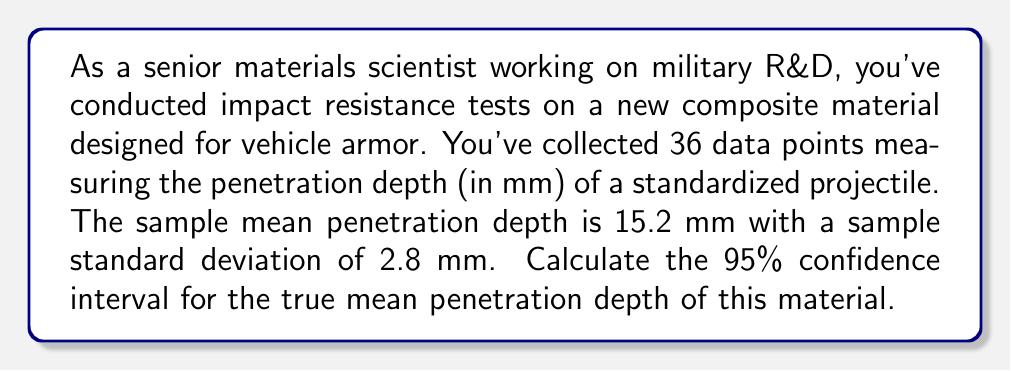Show me your answer to this math problem. To calculate the confidence interval, we'll use the t-distribution since we're working with a sample size less than 30 and don't know the population standard deviation. Here's the step-by-step process:

1. Identify the known values:
   - Sample size: $n = 36$
   - Sample mean: $\bar{x} = 15.2$ mm
   - Sample standard deviation: $s = 2.8$ mm
   - Confidence level: 95% (α = 0.05)

2. Calculate the standard error of the mean:
   $SE = \frac{s}{\sqrt{n}} = \frac{2.8}{\sqrt{36}} = \frac{2.8}{6} = 0.4667$

3. Determine the degrees of freedom:
   $df = n - 1 = 36 - 1 = 35$

4. Find the t-critical value for a 95% confidence interval with 35 degrees of freedom:
   Using a t-table or calculator, we find: $t_{0.025, 35} = 2.0301$

5. Calculate the margin of error:
   $ME = t_{0.025, 35} \times SE = 2.0301 \times 0.4667 = 0.9474$

6. Compute the confidence interval:
   $CI = \bar{x} \pm ME$
   $CI = 15.2 \pm 0.9474$
   $CI = (15.2 - 0.9474, 15.2 + 0.9474)$
   $CI = (14.2526, 16.1474)$

Therefore, we can be 95% confident that the true mean penetration depth for this material lies between 14.2526 mm and 16.1474 mm.
Answer: The 95% confidence interval for the true mean penetration depth is (14.2526 mm, 16.1474 mm). 